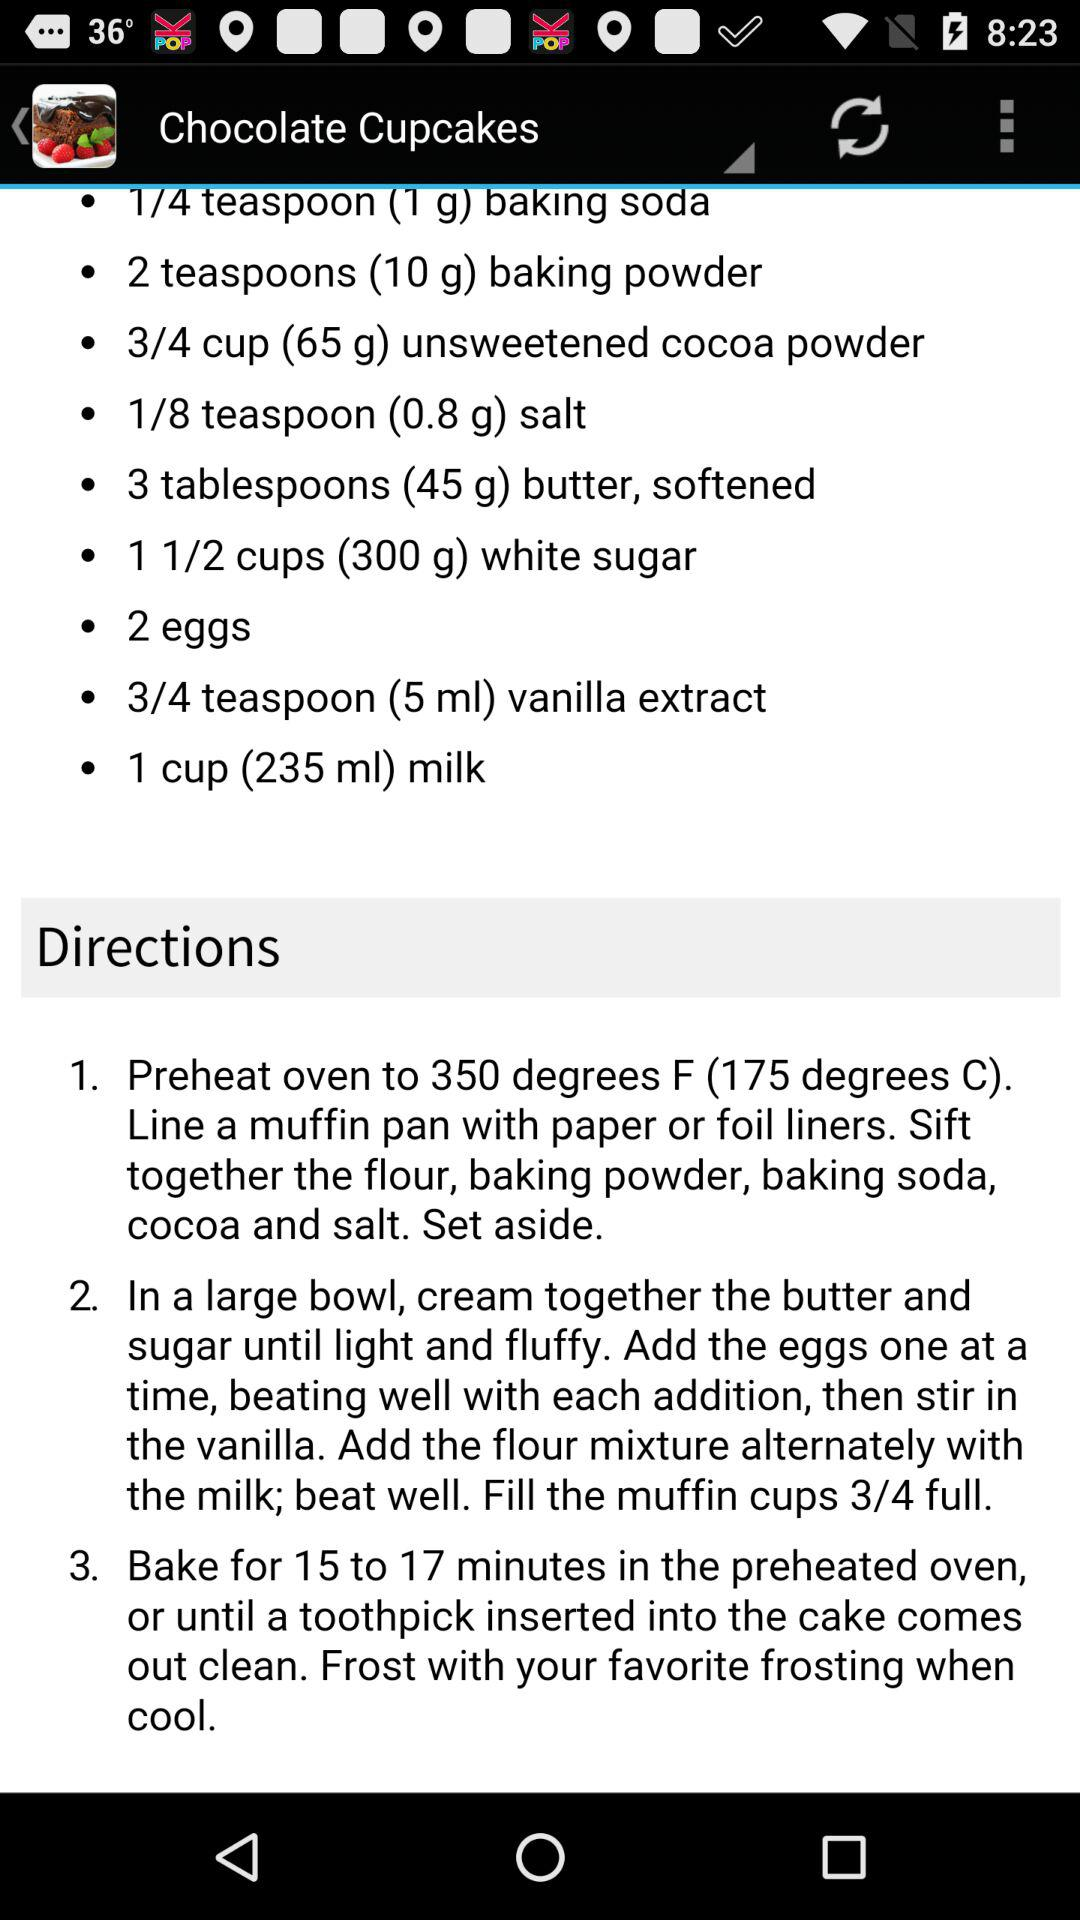How much salt is required for the "Chocolate Cupcakes"? The amount of salt required for the "Chocolate Cupcakes" is 1/8 teaspoon (0.8 g). 